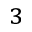Convert formula to latex. <formula><loc_0><loc_0><loc_500><loc_500>^ { 3 }</formula> 